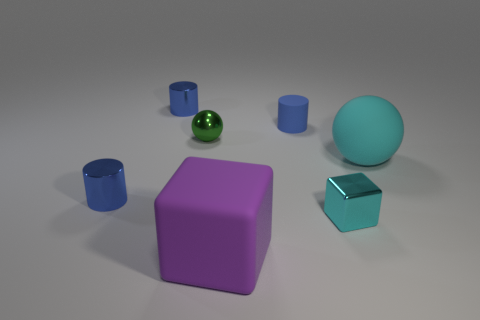Subtract all small blue shiny cylinders. How many cylinders are left? 1 Add 1 tiny metal balls. How many objects exist? 8 Subtract all cylinders. How many objects are left? 4 Subtract 1 spheres. How many spheres are left? 1 Subtract all cyan cubes. Subtract all cyan spheres. How many cubes are left? 1 Subtract all tiny green cubes. Subtract all green things. How many objects are left? 6 Add 3 blue metallic things. How many blue metallic things are left? 5 Add 5 small shiny cubes. How many small shiny cubes exist? 6 Subtract 2 blue cylinders. How many objects are left? 5 